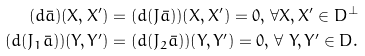<formula> <loc_0><loc_0><loc_500><loc_500>( d { \bar { a } } ) ( X , X ^ { \prime } ) & = ( d ( J { \bar { a } } ) ) ( X , X ^ { \prime } ) = 0 , \, \forall X , X ^ { \prime } \in D ^ { \perp } \\ ( d ( J _ { 1 } { \bar { a } } ) ) ( Y , Y ^ { \prime } ) & = ( d ( J _ { 2 } { \bar { a } } ) ) ( Y , Y ^ { \prime } ) = 0 , \, \forall \ Y , Y ^ { \prime } \in D .</formula> 